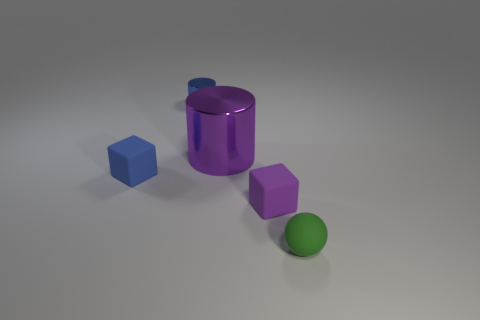Are there any other things that are the same size as the purple shiny cylinder?
Your answer should be compact. No. Is there anything else that has the same shape as the green rubber thing?
Ensure brevity in your answer.  No. Is there any other thing that is the same color as the small metal object?
Give a very brief answer. Yes. There is a purple object that is made of the same material as the tiny blue block; what is its shape?
Your answer should be compact. Cube. What is the material of the small thing that is in front of the purple cube in front of the tiny blue rubber cube?
Keep it short and to the point. Rubber. Does the blue thing that is left of the small blue shiny cylinder have the same shape as the large object?
Ensure brevity in your answer.  No. Is the number of tiny green spheres behind the small ball greater than the number of tiny cyan cylinders?
Provide a succinct answer. No. Is there anything else that is the same material as the tiny cylinder?
Your response must be concise. Yes. There is a thing that is the same color as the tiny cylinder; what is its shape?
Your answer should be very brief. Cube. How many cylinders are either green things or blue rubber objects?
Your answer should be compact. 0. 